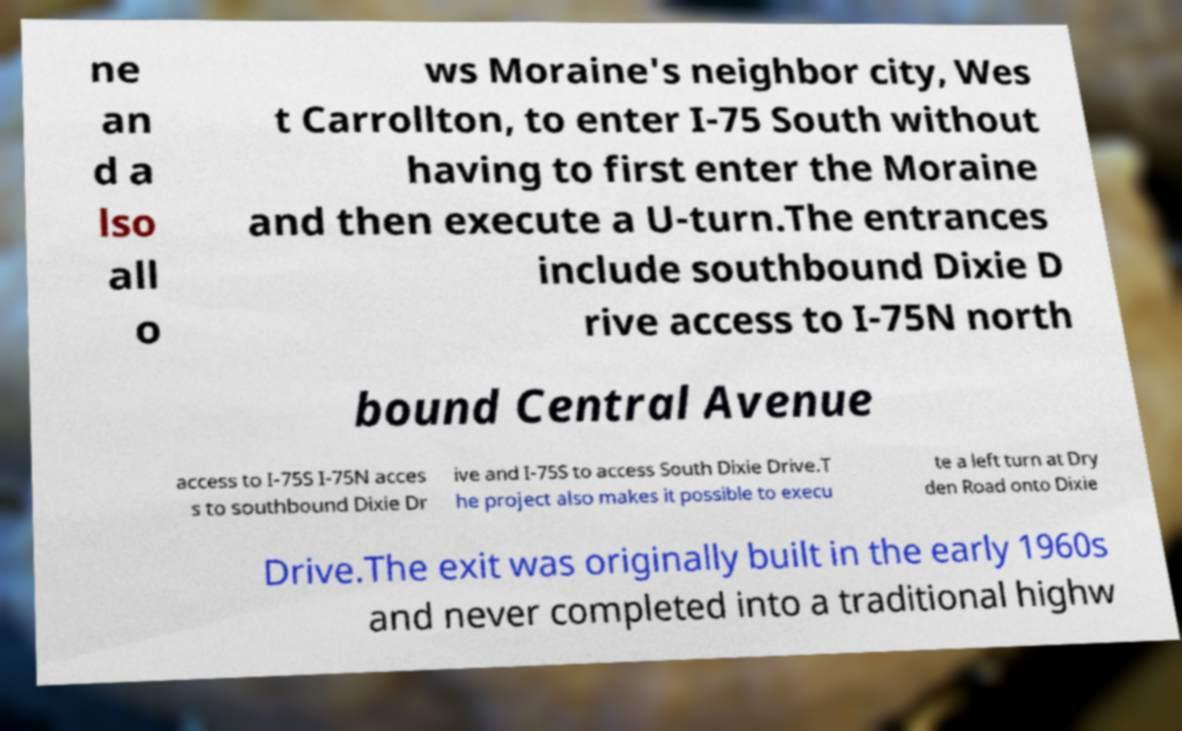Can you accurately transcribe the text from the provided image for me? ne an d a lso all o ws Moraine's neighbor city, Wes t Carrollton, to enter I-75 South without having to first enter the Moraine and then execute a U-turn.The entrances include southbound Dixie D rive access to I-75N north bound Central Avenue access to I-75S I-75N acces s to southbound Dixie Dr ive and I-75S to access South Dixie Drive.T he project also makes it possible to execu te a left turn at Dry den Road onto Dixie Drive.The exit was originally built in the early 1960s and never completed into a traditional highw 